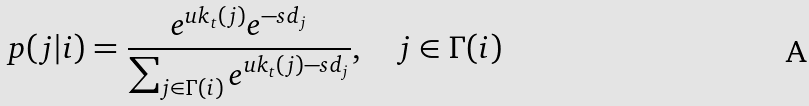<formula> <loc_0><loc_0><loc_500><loc_500>p ( j | i ) = \frac { e ^ { u k _ { t } ( j ) } e ^ { - s d _ { j } } } { \sum _ { j \in \Gamma ( i ) } e ^ { u k _ { t } ( j ) - s d _ { j } } } , \quad j \in \Gamma ( i )</formula> 